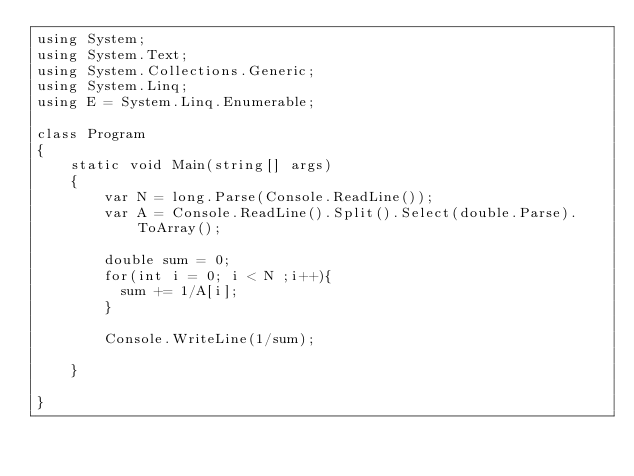Convert code to text. <code><loc_0><loc_0><loc_500><loc_500><_C#_>using System;
using System.Text;
using System.Collections.Generic;
using System.Linq;
using E = System.Linq.Enumerable;

class Program
{
    static void Main(string[] args)
    {   
        var N = long.Parse(Console.ReadLine());
        var A = Console.ReadLine().Split().Select(double.Parse).ToArray();
      
        double sum = 0;
        for(int i = 0; i < N ;i++){
          sum += 1/A[i];
        }

        Console.WriteLine(1/sum);
      
    }

}
</code> 